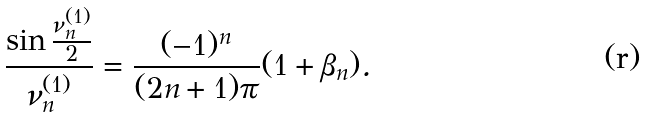<formula> <loc_0><loc_0><loc_500><loc_500>\frac { \sin \frac { \nu _ { n } ^ { ( 1 ) } } { 2 } } { \nu _ { n } ^ { ( 1 ) } } = \frac { ( - 1 ) ^ { n } } { ( 2 n + 1 ) \pi } ( 1 + \beta _ { n } ) .</formula> 